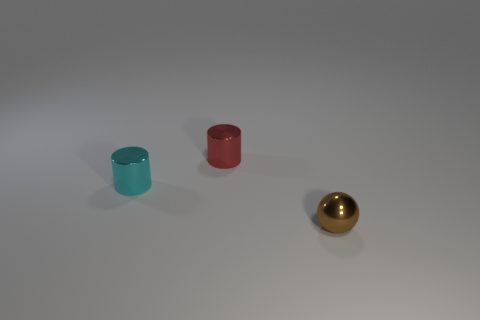Add 3 green cylinders. How many objects exist? 6 Subtract all cyan cylinders. How many cylinders are left? 1 Subtract all spheres. How many objects are left? 2 Subtract 2 cylinders. How many cylinders are left? 0 Subtract all yellow spheres. How many red cylinders are left? 1 Subtract all shiny cylinders. Subtract all tiny spheres. How many objects are left? 0 Add 2 cylinders. How many cylinders are left? 4 Add 3 small red cubes. How many small red cubes exist? 3 Subtract 0 purple cylinders. How many objects are left? 3 Subtract all cyan balls. Subtract all yellow cylinders. How many balls are left? 1 